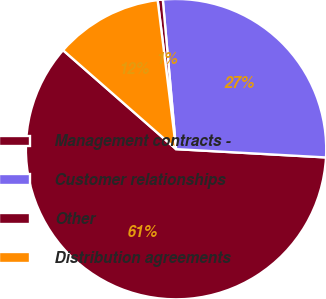Convert chart. <chart><loc_0><loc_0><loc_500><loc_500><pie_chart><fcel>Management contracts -<fcel>Customer relationships<fcel>Other<fcel>Distribution agreements<nl><fcel>60.57%<fcel>27.29%<fcel>0.55%<fcel>11.6%<nl></chart> 